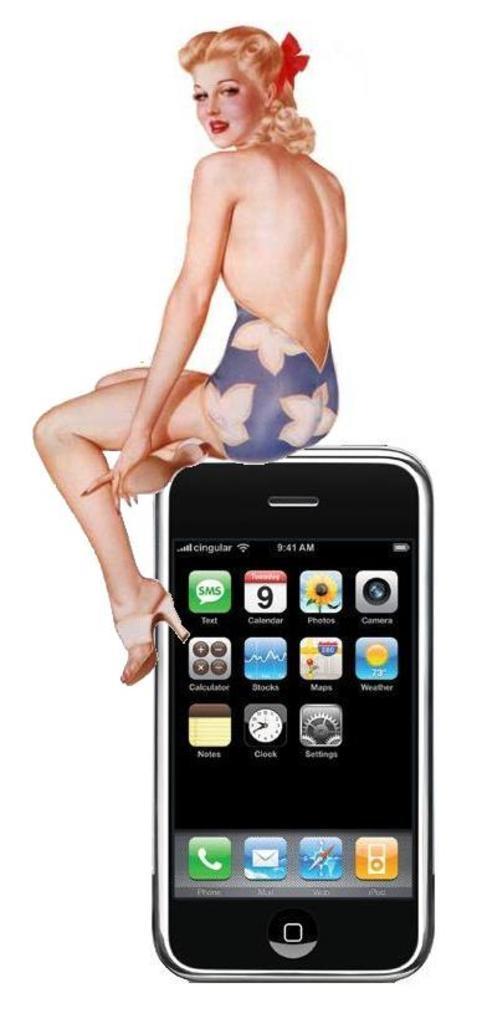In one or two sentences, can you explain what this image depicts? This is an animated image in which there is a mobile phone and there is a image of the woman sitting and smiling. 